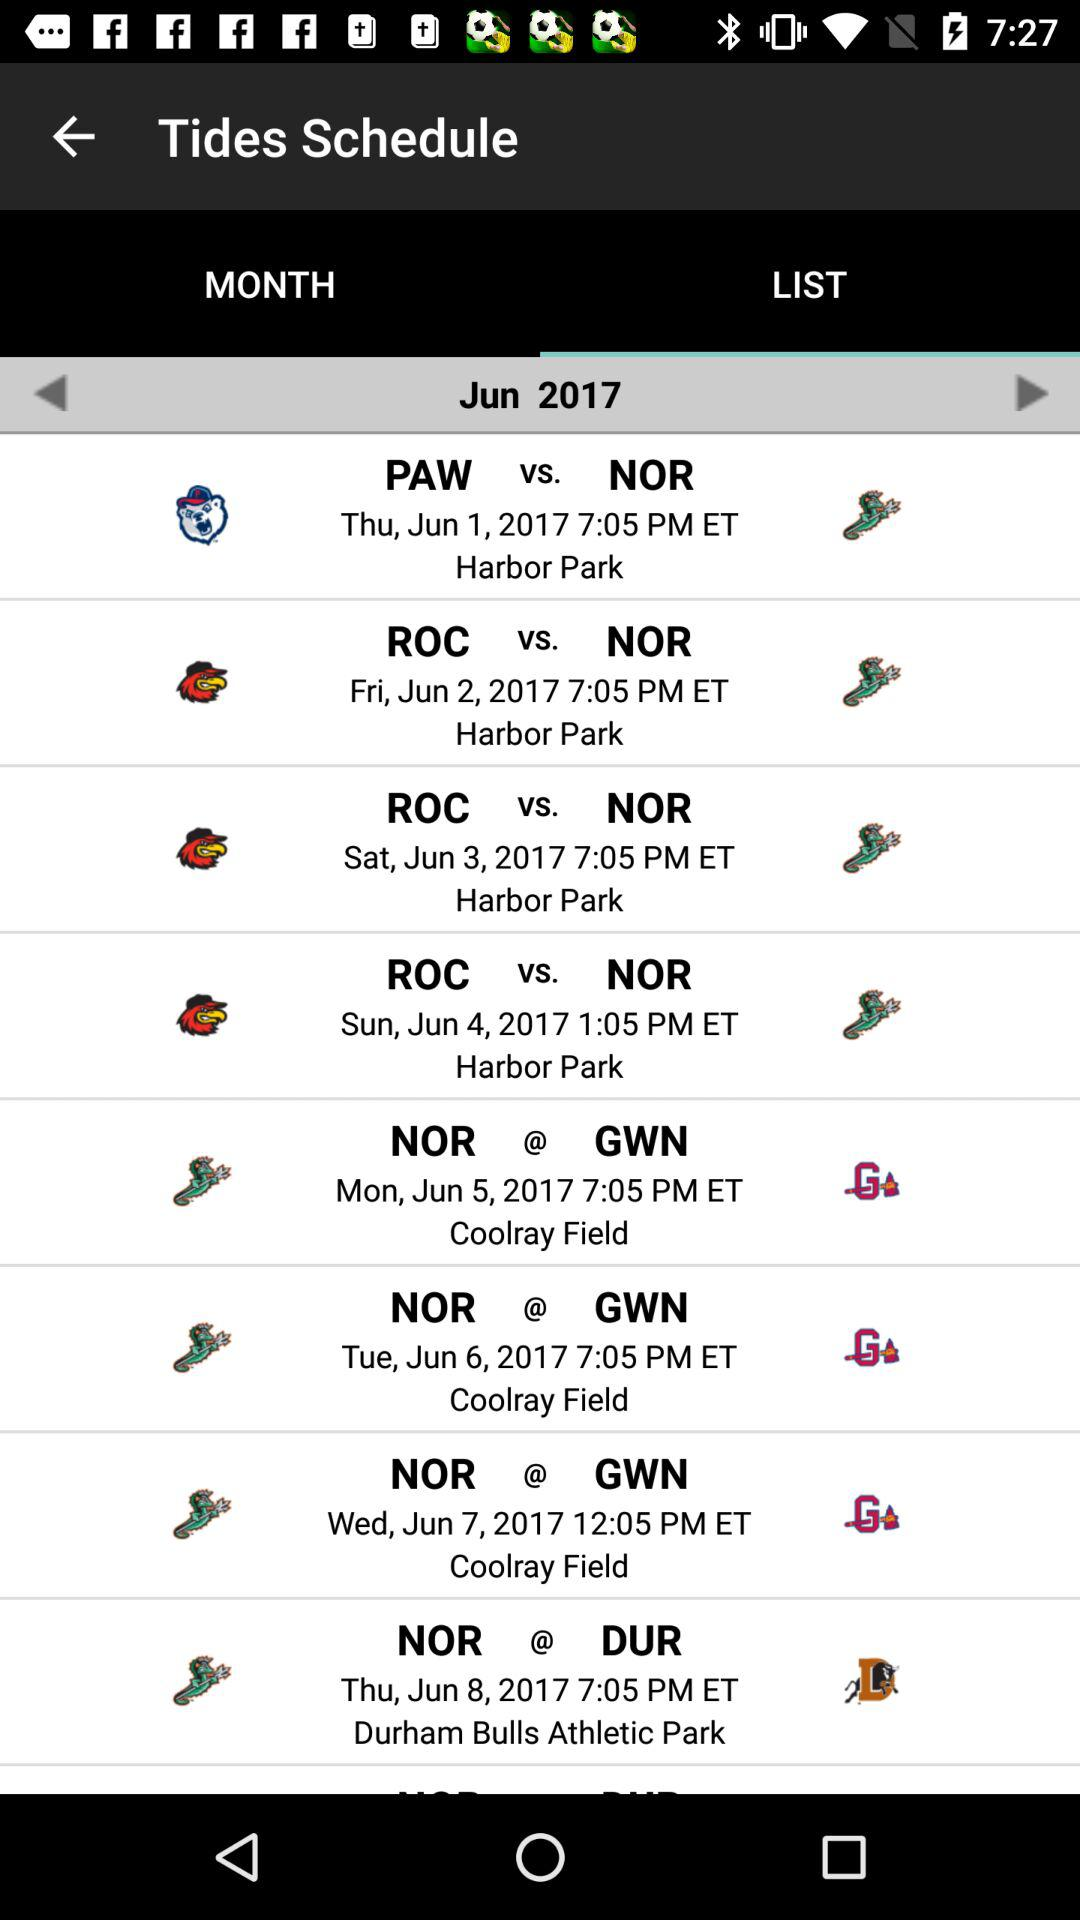At which place is the match played between the ROC versus NOR teams on June 2? The place is Harbor Park. 